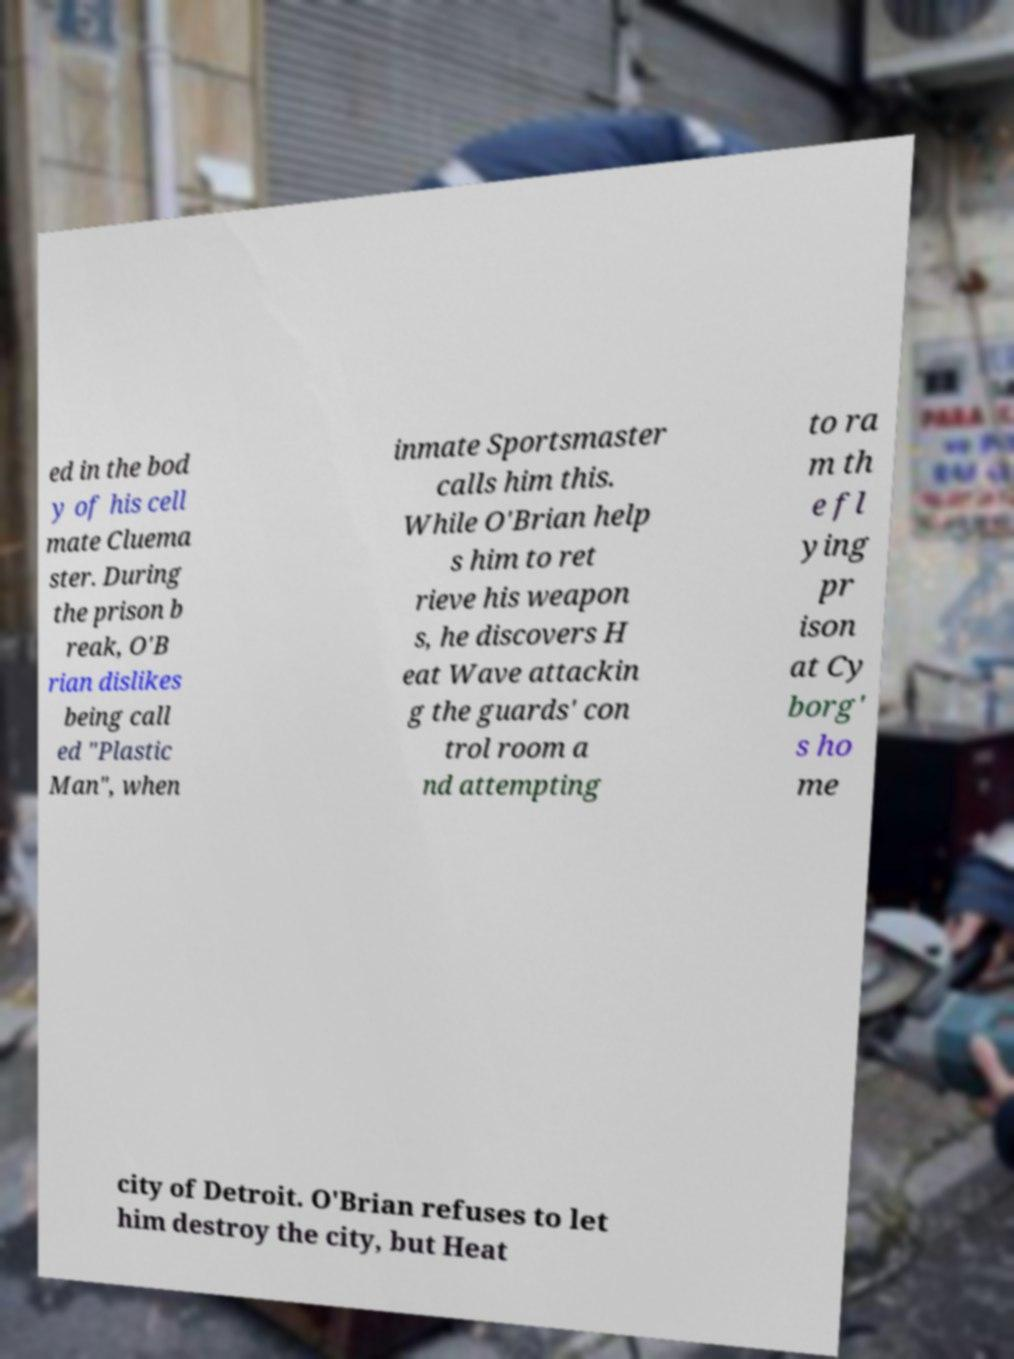Can you read and provide the text displayed in the image?This photo seems to have some interesting text. Can you extract and type it out for me? ed in the bod y of his cell mate Cluema ster. During the prison b reak, O'B rian dislikes being call ed "Plastic Man", when inmate Sportsmaster calls him this. While O'Brian help s him to ret rieve his weapon s, he discovers H eat Wave attackin g the guards' con trol room a nd attempting to ra m th e fl ying pr ison at Cy borg' s ho me city of Detroit. O'Brian refuses to let him destroy the city, but Heat 